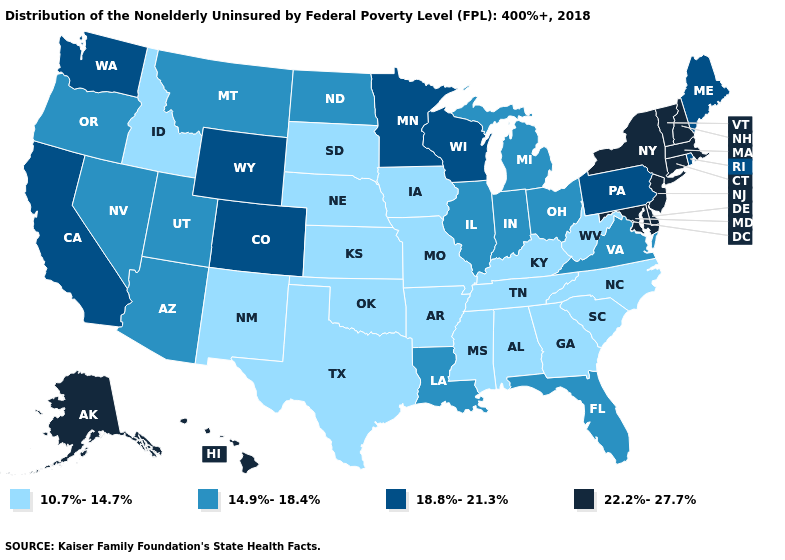Which states have the highest value in the USA?
Be succinct. Alaska, Connecticut, Delaware, Hawaii, Maryland, Massachusetts, New Hampshire, New Jersey, New York, Vermont. Which states have the highest value in the USA?
Quick response, please. Alaska, Connecticut, Delaware, Hawaii, Maryland, Massachusetts, New Hampshire, New Jersey, New York, Vermont. What is the highest value in the South ?
Concise answer only. 22.2%-27.7%. What is the value of Arkansas?
Quick response, please. 10.7%-14.7%. Does Kansas have the highest value in the MidWest?
Write a very short answer. No. What is the value of North Dakota?
Quick response, please. 14.9%-18.4%. Name the states that have a value in the range 10.7%-14.7%?
Write a very short answer. Alabama, Arkansas, Georgia, Idaho, Iowa, Kansas, Kentucky, Mississippi, Missouri, Nebraska, New Mexico, North Carolina, Oklahoma, South Carolina, South Dakota, Tennessee, Texas, West Virginia. Name the states that have a value in the range 10.7%-14.7%?
Short answer required. Alabama, Arkansas, Georgia, Idaho, Iowa, Kansas, Kentucky, Mississippi, Missouri, Nebraska, New Mexico, North Carolina, Oklahoma, South Carolina, South Dakota, Tennessee, Texas, West Virginia. Among the states that border Kansas , which have the highest value?
Short answer required. Colorado. What is the lowest value in the Northeast?
Be succinct. 18.8%-21.3%. Name the states that have a value in the range 10.7%-14.7%?
Keep it brief. Alabama, Arkansas, Georgia, Idaho, Iowa, Kansas, Kentucky, Mississippi, Missouri, Nebraska, New Mexico, North Carolina, Oklahoma, South Carolina, South Dakota, Tennessee, Texas, West Virginia. What is the value of New Hampshire?
Keep it brief. 22.2%-27.7%. What is the lowest value in the Northeast?
Keep it brief. 18.8%-21.3%. What is the value of Wisconsin?
Answer briefly. 18.8%-21.3%. Which states hav the highest value in the West?
Concise answer only. Alaska, Hawaii. 